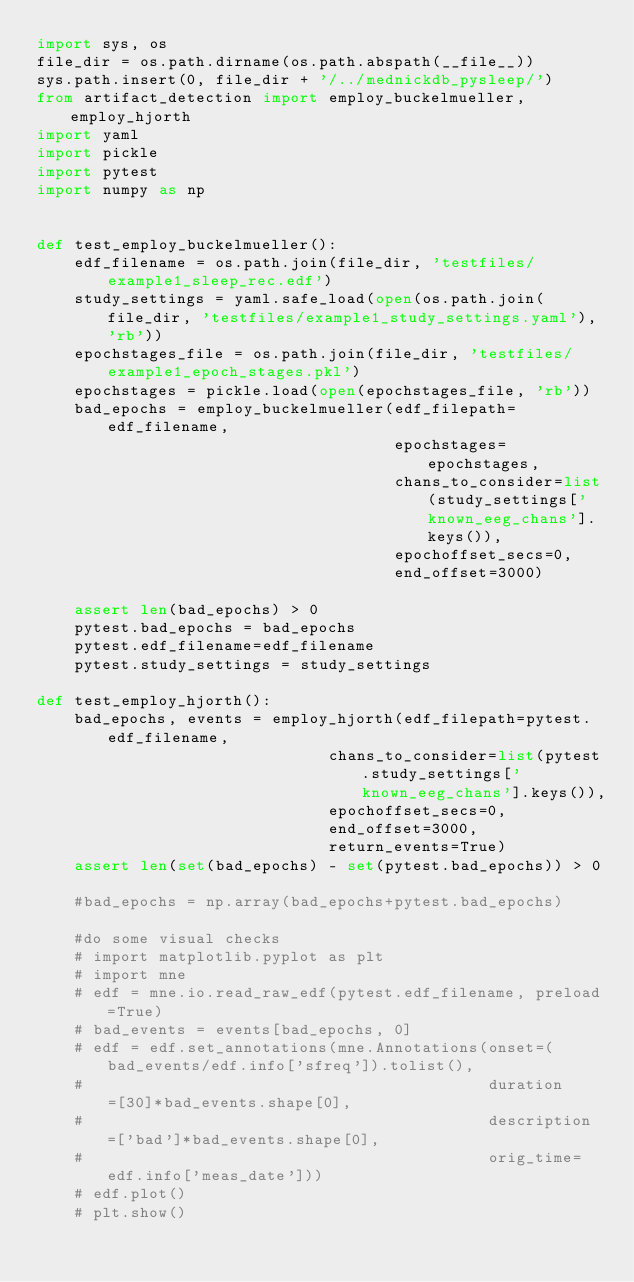Convert code to text. <code><loc_0><loc_0><loc_500><loc_500><_Python_>import sys, os
file_dir = os.path.dirname(os.path.abspath(__file__))
sys.path.insert(0, file_dir + '/../mednickdb_pysleep/')
from artifact_detection import employ_buckelmueller, employ_hjorth
import yaml
import pickle
import pytest
import numpy as np


def test_employ_buckelmueller():
    edf_filename = os.path.join(file_dir, 'testfiles/example1_sleep_rec.edf')
    study_settings = yaml.safe_load(open(os.path.join(file_dir, 'testfiles/example1_study_settings.yaml'), 'rb'))
    epochstages_file = os.path.join(file_dir, 'testfiles/example1_epoch_stages.pkl')
    epochstages = pickle.load(open(epochstages_file, 'rb'))
    bad_epochs = employ_buckelmueller(edf_filepath=edf_filename,
                                      epochstages=epochstages,
                                      chans_to_consider=list(study_settings['known_eeg_chans'].keys()),
                                      epochoffset_secs=0,
                                      end_offset=3000)

    assert len(bad_epochs) > 0
    pytest.bad_epochs = bad_epochs
    pytest.edf_filename=edf_filename
    pytest.study_settings = study_settings

def test_employ_hjorth():
    bad_epochs, events = employ_hjorth(edf_filepath=pytest.edf_filename,
                               chans_to_consider=list(pytest.study_settings['known_eeg_chans'].keys()),
                               epochoffset_secs=0,
                               end_offset=3000,
                               return_events=True)
    assert len(set(bad_epochs) - set(pytest.bad_epochs)) > 0

    #bad_epochs = np.array(bad_epochs+pytest.bad_epochs)

    #do some visual checks
    # import matplotlib.pyplot as plt
    # import mne
    # edf = mne.io.read_raw_edf(pytest.edf_filename, preload=True)
    # bad_events = events[bad_epochs, 0]
    # edf = edf.set_annotations(mne.Annotations(onset=(bad_events/edf.info['sfreq']).tolist(),
    #                                           duration=[30]*bad_events.shape[0],
    #                                           description=['bad']*bad_events.shape[0],
    #                                           orig_time=edf.info['meas_date']))
    # edf.plot()
    # plt.show()</code> 